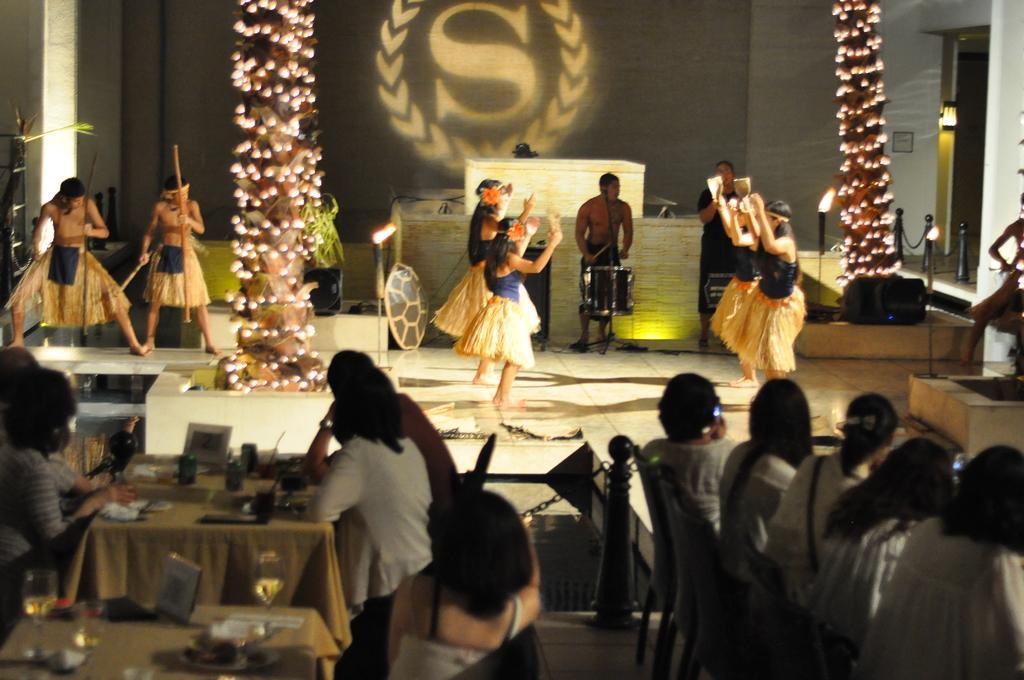Can you describe this image briefly? In this picture we can see some people are sitting on chairs, in front of tables, we can see plates, glasses of drinks and other things present on these tables, in the background there are some people dancing, a person in the middle is playing a drum, on the right side and left side there are lights, we can see queue managing poles on the right side. 